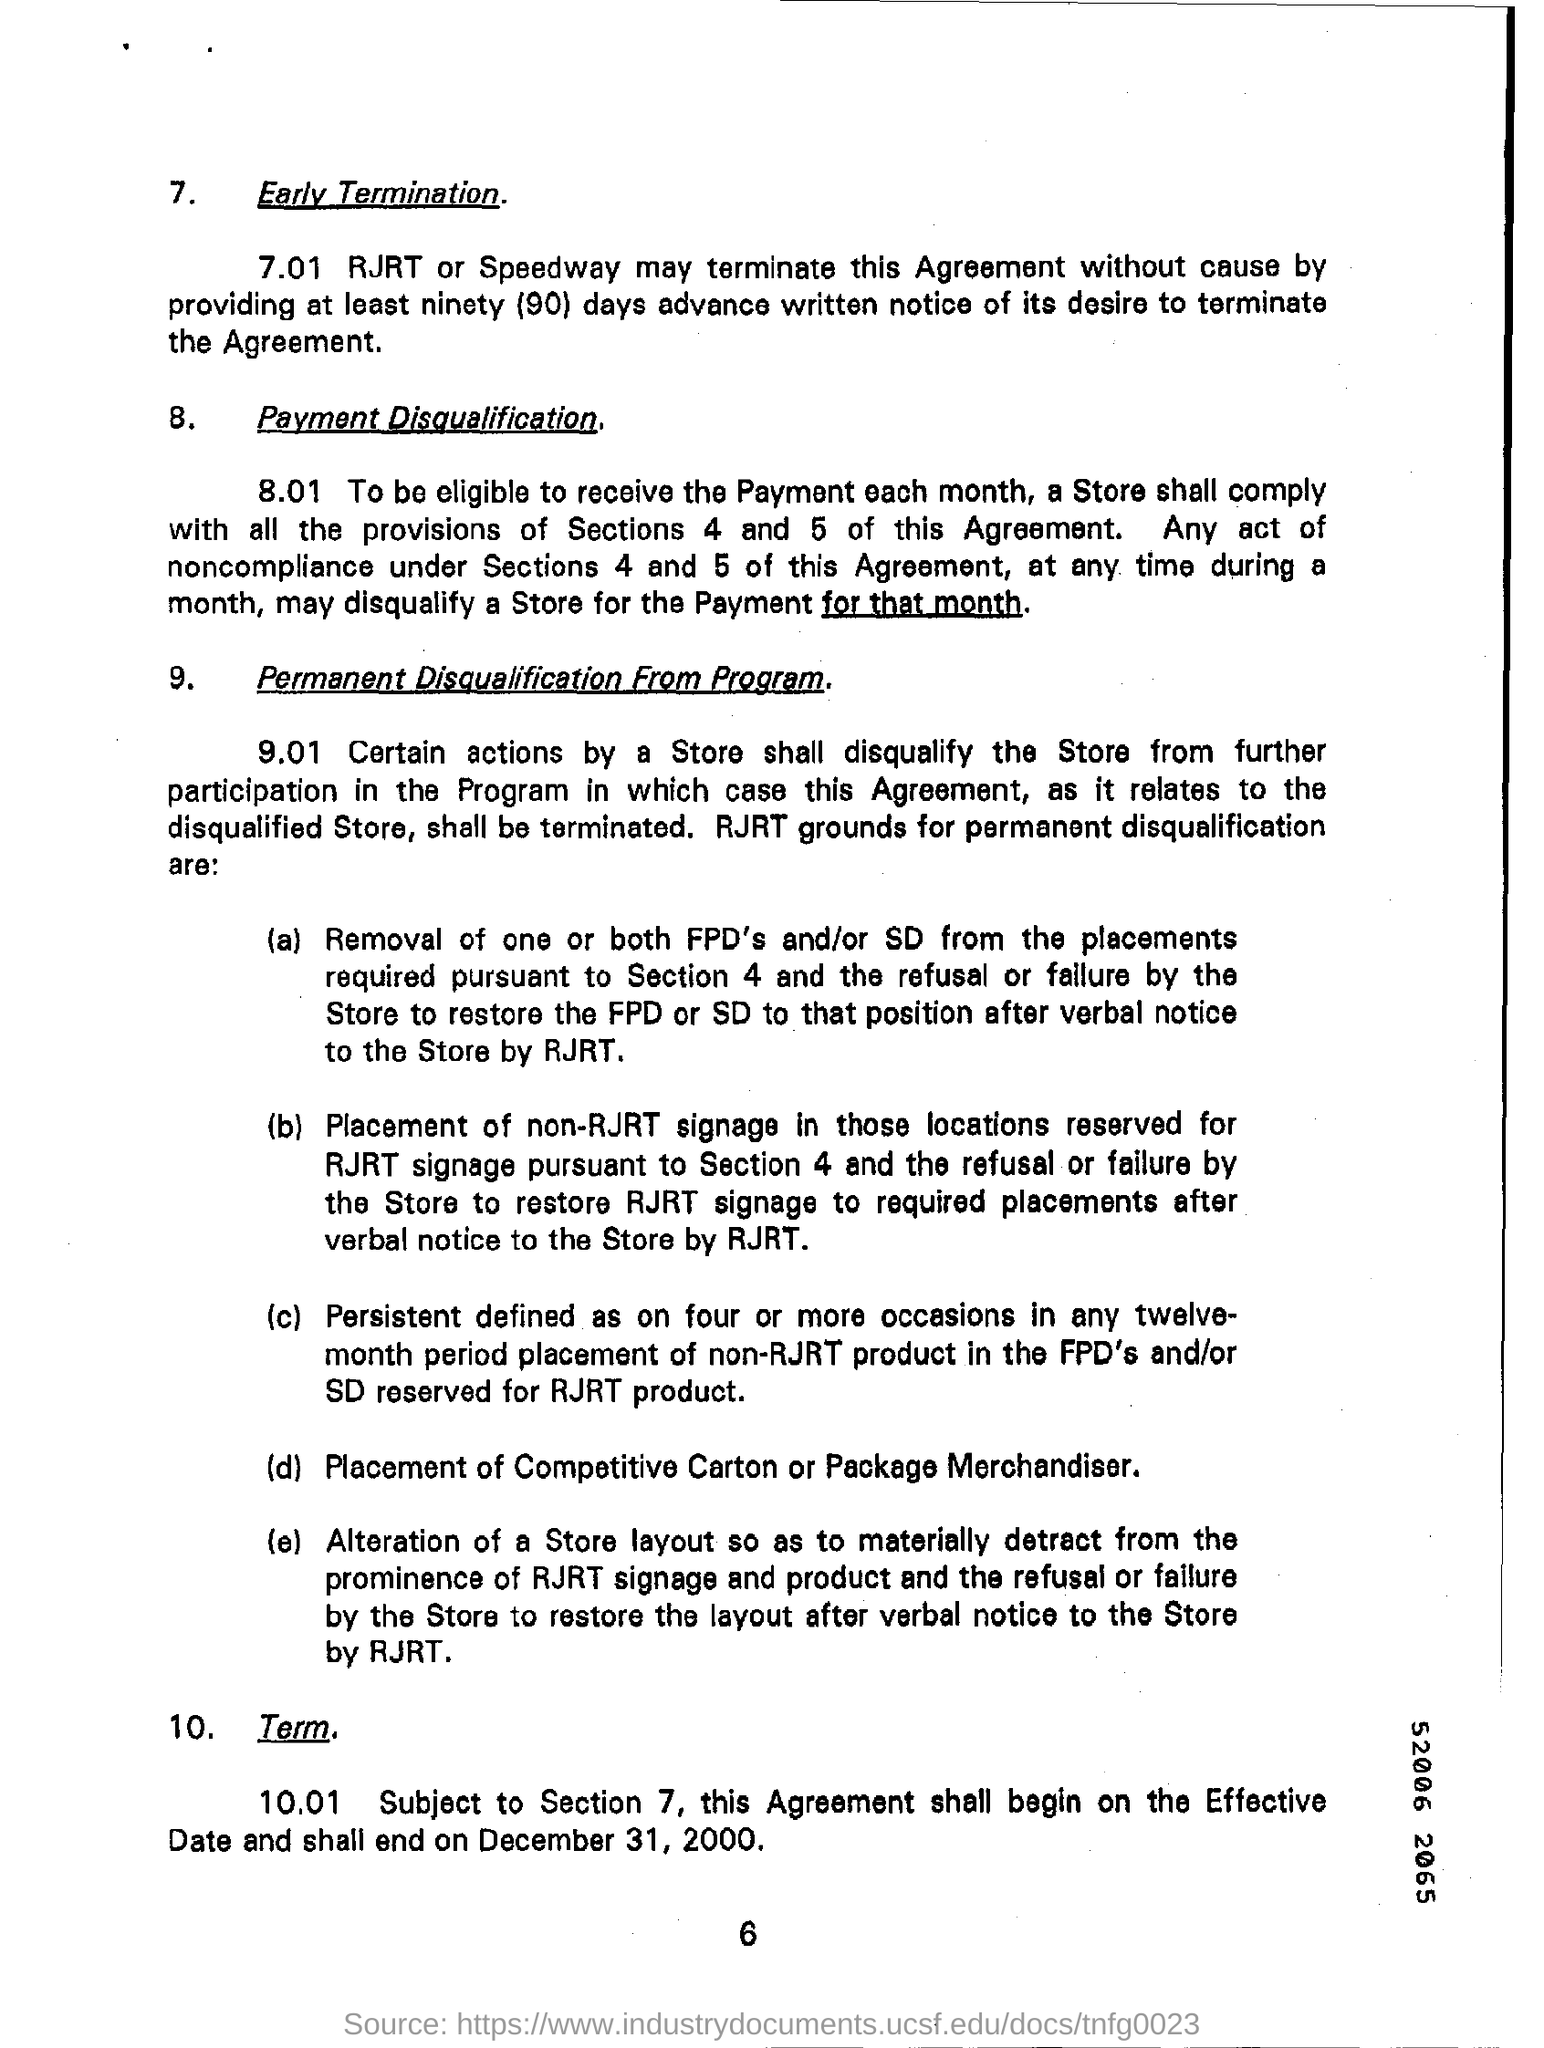What is the number at bottom of the page ?
Your response must be concise. 6. Subject to which section shall  this agreement  begin on the effective date and shall end on december 31,2000?
Your answer should be compact. 7. 